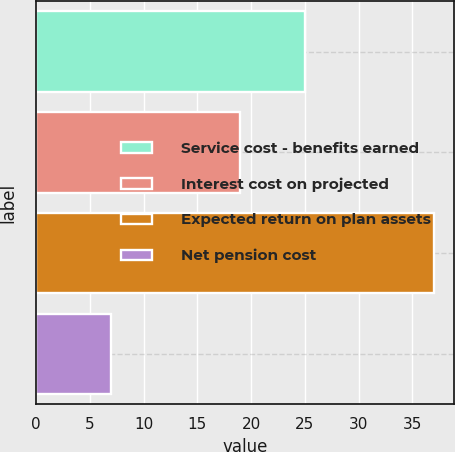Convert chart. <chart><loc_0><loc_0><loc_500><loc_500><bar_chart><fcel>Service cost - benefits earned<fcel>Interest cost on projected<fcel>Expected return on plan assets<fcel>Net pension cost<nl><fcel>25<fcel>19<fcel>37<fcel>7<nl></chart> 